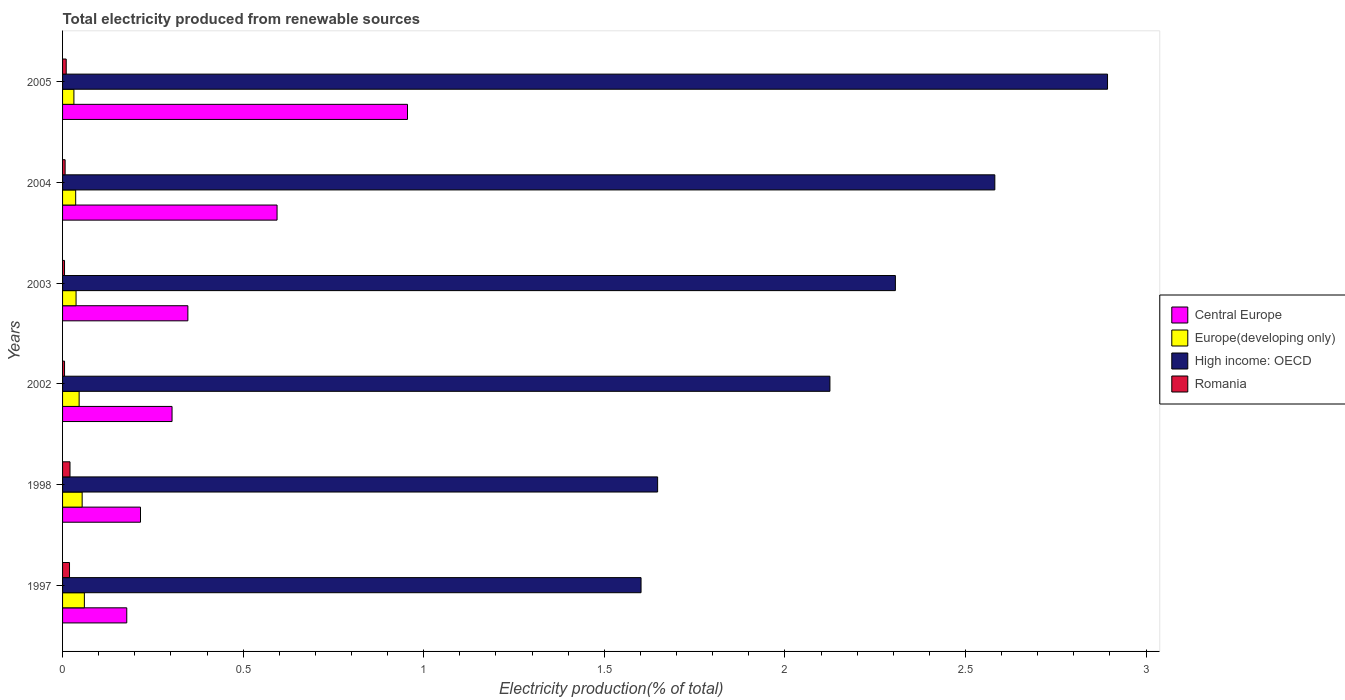How many different coloured bars are there?
Ensure brevity in your answer.  4. How many groups of bars are there?
Provide a short and direct response. 6. Are the number of bars per tick equal to the number of legend labels?
Provide a succinct answer. Yes. Are the number of bars on each tick of the Y-axis equal?
Provide a short and direct response. Yes. How many bars are there on the 2nd tick from the top?
Your answer should be very brief. 4. What is the label of the 1st group of bars from the top?
Provide a short and direct response. 2005. In how many cases, is the number of bars for a given year not equal to the number of legend labels?
Keep it short and to the point. 0. What is the total electricity produced in Romania in 1997?
Your answer should be compact. 0.02. Across all years, what is the maximum total electricity produced in High income: OECD?
Make the answer very short. 2.89. Across all years, what is the minimum total electricity produced in High income: OECD?
Offer a terse response. 1.6. In which year was the total electricity produced in Romania maximum?
Your answer should be very brief. 1998. In which year was the total electricity produced in Romania minimum?
Your answer should be very brief. 2003. What is the total total electricity produced in Central Europe in the graph?
Provide a succinct answer. 2.59. What is the difference between the total electricity produced in Central Europe in 1997 and that in 2003?
Offer a very short reply. -0.17. What is the difference between the total electricity produced in Europe(developing only) in 2004 and the total electricity produced in High income: OECD in 2003?
Give a very brief answer. -2.27. What is the average total electricity produced in High income: OECD per year?
Your response must be concise. 2.19. In the year 2005, what is the difference between the total electricity produced in Europe(developing only) and total electricity produced in High income: OECD?
Provide a short and direct response. -2.86. In how many years, is the total electricity produced in Romania greater than 2.8 %?
Ensure brevity in your answer.  0. What is the ratio of the total electricity produced in Central Europe in 1997 to that in 1998?
Your answer should be very brief. 0.82. What is the difference between the highest and the second highest total electricity produced in Romania?
Your answer should be very brief. 0. What is the difference between the highest and the lowest total electricity produced in Central Europe?
Make the answer very short. 0.78. Is the sum of the total electricity produced in Romania in 1997 and 2004 greater than the maximum total electricity produced in High income: OECD across all years?
Ensure brevity in your answer.  No. What does the 4th bar from the top in 1997 represents?
Make the answer very short. Central Europe. What does the 3rd bar from the bottom in 2003 represents?
Offer a very short reply. High income: OECD. Are all the bars in the graph horizontal?
Ensure brevity in your answer.  Yes. Does the graph contain any zero values?
Provide a short and direct response. No. How are the legend labels stacked?
Your answer should be very brief. Vertical. What is the title of the graph?
Provide a short and direct response. Total electricity produced from renewable sources. What is the Electricity production(% of total) in Central Europe in 1997?
Offer a very short reply. 0.18. What is the Electricity production(% of total) of Europe(developing only) in 1997?
Offer a terse response. 0.06. What is the Electricity production(% of total) of High income: OECD in 1997?
Provide a short and direct response. 1.6. What is the Electricity production(% of total) in Romania in 1997?
Offer a very short reply. 0.02. What is the Electricity production(% of total) in Central Europe in 1998?
Your answer should be compact. 0.22. What is the Electricity production(% of total) in Europe(developing only) in 1998?
Ensure brevity in your answer.  0.05. What is the Electricity production(% of total) of High income: OECD in 1998?
Your answer should be very brief. 1.65. What is the Electricity production(% of total) in Romania in 1998?
Ensure brevity in your answer.  0.02. What is the Electricity production(% of total) of Central Europe in 2002?
Keep it short and to the point. 0.3. What is the Electricity production(% of total) in Europe(developing only) in 2002?
Your answer should be compact. 0.05. What is the Electricity production(% of total) of High income: OECD in 2002?
Make the answer very short. 2.12. What is the Electricity production(% of total) of Romania in 2002?
Your answer should be very brief. 0.01. What is the Electricity production(% of total) of Central Europe in 2003?
Keep it short and to the point. 0.35. What is the Electricity production(% of total) in Europe(developing only) in 2003?
Your answer should be very brief. 0.04. What is the Electricity production(% of total) of High income: OECD in 2003?
Provide a short and direct response. 2.31. What is the Electricity production(% of total) of Romania in 2003?
Keep it short and to the point. 0.01. What is the Electricity production(% of total) in Central Europe in 2004?
Make the answer very short. 0.59. What is the Electricity production(% of total) of Europe(developing only) in 2004?
Offer a very short reply. 0.04. What is the Electricity production(% of total) of High income: OECD in 2004?
Make the answer very short. 2.58. What is the Electricity production(% of total) in Romania in 2004?
Your answer should be compact. 0.01. What is the Electricity production(% of total) of Central Europe in 2005?
Provide a succinct answer. 0.96. What is the Electricity production(% of total) in Europe(developing only) in 2005?
Your answer should be compact. 0.03. What is the Electricity production(% of total) in High income: OECD in 2005?
Provide a short and direct response. 2.89. What is the Electricity production(% of total) in Romania in 2005?
Your answer should be compact. 0.01. Across all years, what is the maximum Electricity production(% of total) of Central Europe?
Your response must be concise. 0.96. Across all years, what is the maximum Electricity production(% of total) of Europe(developing only)?
Offer a very short reply. 0.06. Across all years, what is the maximum Electricity production(% of total) in High income: OECD?
Provide a succinct answer. 2.89. Across all years, what is the maximum Electricity production(% of total) in Romania?
Give a very brief answer. 0.02. Across all years, what is the minimum Electricity production(% of total) of Central Europe?
Ensure brevity in your answer.  0.18. Across all years, what is the minimum Electricity production(% of total) of Europe(developing only)?
Your answer should be very brief. 0.03. Across all years, what is the minimum Electricity production(% of total) in High income: OECD?
Provide a short and direct response. 1.6. Across all years, what is the minimum Electricity production(% of total) in Romania?
Ensure brevity in your answer.  0.01. What is the total Electricity production(% of total) in Central Europe in the graph?
Offer a very short reply. 2.59. What is the total Electricity production(% of total) in Europe(developing only) in the graph?
Make the answer very short. 0.27. What is the total Electricity production(% of total) in High income: OECD in the graph?
Your response must be concise. 13.15. What is the total Electricity production(% of total) in Romania in the graph?
Give a very brief answer. 0.07. What is the difference between the Electricity production(% of total) in Central Europe in 1997 and that in 1998?
Ensure brevity in your answer.  -0.04. What is the difference between the Electricity production(% of total) in Europe(developing only) in 1997 and that in 1998?
Provide a succinct answer. 0.01. What is the difference between the Electricity production(% of total) of High income: OECD in 1997 and that in 1998?
Provide a succinct answer. -0.05. What is the difference between the Electricity production(% of total) of Romania in 1997 and that in 1998?
Provide a short and direct response. -0. What is the difference between the Electricity production(% of total) of Central Europe in 1997 and that in 2002?
Give a very brief answer. -0.13. What is the difference between the Electricity production(% of total) of Europe(developing only) in 1997 and that in 2002?
Your answer should be compact. 0.01. What is the difference between the Electricity production(% of total) of High income: OECD in 1997 and that in 2002?
Keep it short and to the point. -0.52. What is the difference between the Electricity production(% of total) in Romania in 1997 and that in 2002?
Offer a very short reply. 0.01. What is the difference between the Electricity production(% of total) in Central Europe in 1997 and that in 2003?
Offer a very short reply. -0.17. What is the difference between the Electricity production(% of total) of Europe(developing only) in 1997 and that in 2003?
Your answer should be very brief. 0.02. What is the difference between the Electricity production(% of total) in High income: OECD in 1997 and that in 2003?
Offer a terse response. -0.7. What is the difference between the Electricity production(% of total) of Romania in 1997 and that in 2003?
Provide a succinct answer. 0.01. What is the difference between the Electricity production(% of total) of Central Europe in 1997 and that in 2004?
Your answer should be very brief. -0.42. What is the difference between the Electricity production(% of total) in Europe(developing only) in 1997 and that in 2004?
Provide a short and direct response. 0.02. What is the difference between the Electricity production(% of total) in High income: OECD in 1997 and that in 2004?
Keep it short and to the point. -0.98. What is the difference between the Electricity production(% of total) in Romania in 1997 and that in 2004?
Offer a very short reply. 0.01. What is the difference between the Electricity production(% of total) in Central Europe in 1997 and that in 2005?
Your answer should be compact. -0.78. What is the difference between the Electricity production(% of total) in Europe(developing only) in 1997 and that in 2005?
Your answer should be compact. 0.03. What is the difference between the Electricity production(% of total) of High income: OECD in 1997 and that in 2005?
Make the answer very short. -1.29. What is the difference between the Electricity production(% of total) of Romania in 1997 and that in 2005?
Make the answer very short. 0.01. What is the difference between the Electricity production(% of total) in Central Europe in 1998 and that in 2002?
Your answer should be compact. -0.09. What is the difference between the Electricity production(% of total) of Europe(developing only) in 1998 and that in 2002?
Your response must be concise. 0.01. What is the difference between the Electricity production(% of total) in High income: OECD in 1998 and that in 2002?
Your response must be concise. -0.48. What is the difference between the Electricity production(% of total) in Romania in 1998 and that in 2002?
Provide a short and direct response. 0.02. What is the difference between the Electricity production(% of total) of Central Europe in 1998 and that in 2003?
Provide a short and direct response. -0.13. What is the difference between the Electricity production(% of total) of Europe(developing only) in 1998 and that in 2003?
Provide a succinct answer. 0.02. What is the difference between the Electricity production(% of total) in High income: OECD in 1998 and that in 2003?
Your answer should be compact. -0.66. What is the difference between the Electricity production(% of total) of Romania in 1998 and that in 2003?
Offer a terse response. 0.02. What is the difference between the Electricity production(% of total) of Central Europe in 1998 and that in 2004?
Provide a succinct answer. -0.38. What is the difference between the Electricity production(% of total) in Europe(developing only) in 1998 and that in 2004?
Your answer should be compact. 0.02. What is the difference between the Electricity production(% of total) of High income: OECD in 1998 and that in 2004?
Provide a short and direct response. -0.93. What is the difference between the Electricity production(% of total) in Romania in 1998 and that in 2004?
Your response must be concise. 0.01. What is the difference between the Electricity production(% of total) in Central Europe in 1998 and that in 2005?
Offer a very short reply. -0.74. What is the difference between the Electricity production(% of total) in Europe(developing only) in 1998 and that in 2005?
Provide a short and direct response. 0.02. What is the difference between the Electricity production(% of total) in High income: OECD in 1998 and that in 2005?
Offer a terse response. -1.25. What is the difference between the Electricity production(% of total) of Romania in 1998 and that in 2005?
Your answer should be very brief. 0.01. What is the difference between the Electricity production(% of total) of Central Europe in 2002 and that in 2003?
Make the answer very short. -0.04. What is the difference between the Electricity production(% of total) in Europe(developing only) in 2002 and that in 2003?
Offer a terse response. 0.01. What is the difference between the Electricity production(% of total) of High income: OECD in 2002 and that in 2003?
Provide a short and direct response. -0.18. What is the difference between the Electricity production(% of total) of Romania in 2002 and that in 2003?
Provide a short and direct response. 0. What is the difference between the Electricity production(% of total) of Central Europe in 2002 and that in 2004?
Offer a very short reply. -0.29. What is the difference between the Electricity production(% of total) of Europe(developing only) in 2002 and that in 2004?
Make the answer very short. 0.01. What is the difference between the Electricity production(% of total) in High income: OECD in 2002 and that in 2004?
Make the answer very short. -0.46. What is the difference between the Electricity production(% of total) of Romania in 2002 and that in 2004?
Ensure brevity in your answer.  -0. What is the difference between the Electricity production(% of total) of Central Europe in 2002 and that in 2005?
Ensure brevity in your answer.  -0.65. What is the difference between the Electricity production(% of total) in Europe(developing only) in 2002 and that in 2005?
Provide a succinct answer. 0.01. What is the difference between the Electricity production(% of total) of High income: OECD in 2002 and that in 2005?
Offer a terse response. -0.77. What is the difference between the Electricity production(% of total) of Romania in 2002 and that in 2005?
Offer a very short reply. -0. What is the difference between the Electricity production(% of total) in Central Europe in 2003 and that in 2004?
Provide a short and direct response. -0.25. What is the difference between the Electricity production(% of total) of High income: OECD in 2003 and that in 2004?
Your answer should be very brief. -0.28. What is the difference between the Electricity production(% of total) in Romania in 2003 and that in 2004?
Your answer should be very brief. -0. What is the difference between the Electricity production(% of total) of Central Europe in 2003 and that in 2005?
Your response must be concise. -0.61. What is the difference between the Electricity production(% of total) in Europe(developing only) in 2003 and that in 2005?
Keep it short and to the point. 0.01. What is the difference between the Electricity production(% of total) in High income: OECD in 2003 and that in 2005?
Ensure brevity in your answer.  -0.59. What is the difference between the Electricity production(% of total) in Romania in 2003 and that in 2005?
Make the answer very short. -0. What is the difference between the Electricity production(% of total) in Central Europe in 2004 and that in 2005?
Provide a succinct answer. -0.36. What is the difference between the Electricity production(% of total) in Europe(developing only) in 2004 and that in 2005?
Give a very brief answer. 0. What is the difference between the Electricity production(% of total) of High income: OECD in 2004 and that in 2005?
Ensure brevity in your answer.  -0.31. What is the difference between the Electricity production(% of total) of Romania in 2004 and that in 2005?
Your answer should be very brief. -0. What is the difference between the Electricity production(% of total) in Central Europe in 1997 and the Electricity production(% of total) in Europe(developing only) in 1998?
Make the answer very short. 0.12. What is the difference between the Electricity production(% of total) in Central Europe in 1997 and the Electricity production(% of total) in High income: OECD in 1998?
Make the answer very short. -1.47. What is the difference between the Electricity production(% of total) of Central Europe in 1997 and the Electricity production(% of total) of Romania in 1998?
Keep it short and to the point. 0.16. What is the difference between the Electricity production(% of total) of Europe(developing only) in 1997 and the Electricity production(% of total) of High income: OECD in 1998?
Give a very brief answer. -1.59. What is the difference between the Electricity production(% of total) of Europe(developing only) in 1997 and the Electricity production(% of total) of Romania in 1998?
Your answer should be compact. 0.04. What is the difference between the Electricity production(% of total) in High income: OECD in 1997 and the Electricity production(% of total) in Romania in 1998?
Provide a short and direct response. 1.58. What is the difference between the Electricity production(% of total) of Central Europe in 1997 and the Electricity production(% of total) of Europe(developing only) in 2002?
Make the answer very short. 0.13. What is the difference between the Electricity production(% of total) in Central Europe in 1997 and the Electricity production(% of total) in High income: OECD in 2002?
Your answer should be compact. -1.95. What is the difference between the Electricity production(% of total) in Central Europe in 1997 and the Electricity production(% of total) in Romania in 2002?
Provide a succinct answer. 0.17. What is the difference between the Electricity production(% of total) in Europe(developing only) in 1997 and the Electricity production(% of total) in High income: OECD in 2002?
Provide a succinct answer. -2.06. What is the difference between the Electricity production(% of total) in Europe(developing only) in 1997 and the Electricity production(% of total) in Romania in 2002?
Keep it short and to the point. 0.05. What is the difference between the Electricity production(% of total) of High income: OECD in 1997 and the Electricity production(% of total) of Romania in 2002?
Your answer should be very brief. 1.6. What is the difference between the Electricity production(% of total) of Central Europe in 1997 and the Electricity production(% of total) of Europe(developing only) in 2003?
Provide a succinct answer. 0.14. What is the difference between the Electricity production(% of total) of Central Europe in 1997 and the Electricity production(% of total) of High income: OECD in 2003?
Offer a terse response. -2.13. What is the difference between the Electricity production(% of total) in Central Europe in 1997 and the Electricity production(% of total) in Romania in 2003?
Offer a very short reply. 0.17. What is the difference between the Electricity production(% of total) in Europe(developing only) in 1997 and the Electricity production(% of total) in High income: OECD in 2003?
Make the answer very short. -2.25. What is the difference between the Electricity production(% of total) in Europe(developing only) in 1997 and the Electricity production(% of total) in Romania in 2003?
Offer a terse response. 0.05. What is the difference between the Electricity production(% of total) of High income: OECD in 1997 and the Electricity production(% of total) of Romania in 2003?
Keep it short and to the point. 1.6. What is the difference between the Electricity production(% of total) of Central Europe in 1997 and the Electricity production(% of total) of Europe(developing only) in 2004?
Keep it short and to the point. 0.14. What is the difference between the Electricity production(% of total) in Central Europe in 1997 and the Electricity production(% of total) in High income: OECD in 2004?
Provide a succinct answer. -2.4. What is the difference between the Electricity production(% of total) in Central Europe in 1997 and the Electricity production(% of total) in Romania in 2004?
Provide a succinct answer. 0.17. What is the difference between the Electricity production(% of total) of Europe(developing only) in 1997 and the Electricity production(% of total) of High income: OECD in 2004?
Provide a succinct answer. -2.52. What is the difference between the Electricity production(% of total) of Europe(developing only) in 1997 and the Electricity production(% of total) of Romania in 2004?
Your response must be concise. 0.05. What is the difference between the Electricity production(% of total) of High income: OECD in 1997 and the Electricity production(% of total) of Romania in 2004?
Keep it short and to the point. 1.59. What is the difference between the Electricity production(% of total) of Central Europe in 1997 and the Electricity production(% of total) of Europe(developing only) in 2005?
Ensure brevity in your answer.  0.15. What is the difference between the Electricity production(% of total) in Central Europe in 1997 and the Electricity production(% of total) in High income: OECD in 2005?
Give a very brief answer. -2.72. What is the difference between the Electricity production(% of total) of Central Europe in 1997 and the Electricity production(% of total) of Romania in 2005?
Offer a very short reply. 0.17. What is the difference between the Electricity production(% of total) of Europe(developing only) in 1997 and the Electricity production(% of total) of High income: OECD in 2005?
Your response must be concise. -2.83. What is the difference between the Electricity production(% of total) of Europe(developing only) in 1997 and the Electricity production(% of total) of Romania in 2005?
Provide a succinct answer. 0.05. What is the difference between the Electricity production(% of total) in High income: OECD in 1997 and the Electricity production(% of total) in Romania in 2005?
Your answer should be very brief. 1.59. What is the difference between the Electricity production(% of total) of Central Europe in 1998 and the Electricity production(% of total) of Europe(developing only) in 2002?
Offer a terse response. 0.17. What is the difference between the Electricity production(% of total) in Central Europe in 1998 and the Electricity production(% of total) in High income: OECD in 2002?
Provide a succinct answer. -1.91. What is the difference between the Electricity production(% of total) of Central Europe in 1998 and the Electricity production(% of total) of Romania in 2002?
Keep it short and to the point. 0.21. What is the difference between the Electricity production(% of total) of Europe(developing only) in 1998 and the Electricity production(% of total) of High income: OECD in 2002?
Ensure brevity in your answer.  -2.07. What is the difference between the Electricity production(% of total) of Europe(developing only) in 1998 and the Electricity production(% of total) of Romania in 2002?
Offer a terse response. 0.05. What is the difference between the Electricity production(% of total) in High income: OECD in 1998 and the Electricity production(% of total) in Romania in 2002?
Provide a short and direct response. 1.64. What is the difference between the Electricity production(% of total) of Central Europe in 1998 and the Electricity production(% of total) of Europe(developing only) in 2003?
Your response must be concise. 0.18. What is the difference between the Electricity production(% of total) of Central Europe in 1998 and the Electricity production(% of total) of High income: OECD in 2003?
Provide a short and direct response. -2.09. What is the difference between the Electricity production(% of total) in Central Europe in 1998 and the Electricity production(% of total) in Romania in 2003?
Offer a terse response. 0.21. What is the difference between the Electricity production(% of total) of Europe(developing only) in 1998 and the Electricity production(% of total) of High income: OECD in 2003?
Your response must be concise. -2.25. What is the difference between the Electricity production(% of total) of Europe(developing only) in 1998 and the Electricity production(% of total) of Romania in 2003?
Your answer should be very brief. 0.05. What is the difference between the Electricity production(% of total) of High income: OECD in 1998 and the Electricity production(% of total) of Romania in 2003?
Ensure brevity in your answer.  1.64. What is the difference between the Electricity production(% of total) of Central Europe in 1998 and the Electricity production(% of total) of Europe(developing only) in 2004?
Provide a succinct answer. 0.18. What is the difference between the Electricity production(% of total) of Central Europe in 1998 and the Electricity production(% of total) of High income: OECD in 2004?
Provide a short and direct response. -2.37. What is the difference between the Electricity production(% of total) in Central Europe in 1998 and the Electricity production(% of total) in Romania in 2004?
Offer a very short reply. 0.21. What is the difference between the Electricity production(% of total) of Europe(developing only) in 1998 and the Electricity production(% of total) of High income: OECD in 2004?
Provide a short and direct response. -2.53. What is the difference between the Electricity production(% of total) in Europe(developing only) in 1998 and the Electricity production(% of total) in Romania in 2004?
Keep it short and to the point. 0.05. What is the difference between the Electricity production(% of total) in High income: OECD in 1998 and the Electricity production(% of total) in Romania in 2004?
Provide a succinct answer. 1.64. What is the difference between the Electricity production(% of total) in Central Europe in 1998 and the Electricity production(% of total) in Europe(developing only) in 2005?
Your answer should be compact. 0.18. What is the difference between the Electricity production(% of total) of Central Europe in 1998 and the Electricity production(% of total) of High income: OECD in 2005?
Your answer should be compact. -2.68. What is the difference between the Electricity production(% of total) in Central Europe in 1998 and the Electricity production(% of total) in Romania in 2005?
Provide a short and direct response. 0.21. What is the difference between the Electricity production(% of total) in Europe(developing only) in 1998 and the Electricity production(% of total) in High income: OECD in 2005?
Offer a terse response. -2.84. What is the difference between the Electricity production(% of total) of Europe(developing only) in 1998 and the Electricity production(% of total) of Romania in 2005?
Your response must be concise. 0.04. What is the difference between the Electricity production(% of total) of High income: OECD in 1998 and the Electricity production(% of total) of Romania in 2005?
Make the answer very short. 1.64. What is the difference between the Electricity production(% of total) in Central Europe in 2002 and the Electricity production(% of total) in Europe(developing only) in 2003?
Your response must be concise. 0.27. What is the difference between the Electricity production(% of total) of Central Europe in 2002 and the Electricity production(% of total) of High income: OECD in 2003?
Ensure brevity in your answer.  -2. What is the difference between the Electricity production(% of total) in Central Europe in 2002 and the Electricity production(% of total) in Romania in 2003?
Provide a succinct answer. 0.3. What is the difference between the Electricity production(% of total) in Europe(developing only) in 2002 and the Electricity production(% of total) in High income: OECD in 2003?
Your answer should be very brief. -2.26. What is the difference between the Electricity production(% of total) of Europe(developing only) in 2002 and the Electricity production(% of total) of Romania in 2003?
Your answer should be very brief. 0.04. What is the difference between the Electricity production(% of total) of High income: OECD in 2002 and the Electricity production(% of total) of Romania in 2003?
Your answer should be compact. 2.12. What is the difference between the Electricity production(% of total) in Central Europe in 2002 and the Electricity production(% of total) in Europe(developing only) in 2004?
Provide a succinct answer. 0.27. What is the difference between the Electricity production(% of total) in Central Europe in 2002 and the Electricity production(% of total) in High income: OECD in 2004?
Give a very brief answer. -2.28. What is the difference between the Electricity production(% of total) of Central Europe in 2002 and the Electricity production(% of total) of Romania in 2004?
Make the answer very short. 0.3. What is the difference between the Electricity production(% of total) in Europe(developing only) in 2002 and the Electricity production(% of total) in High income: OECD in 2004?
Offer a terse response. -2.54. What is the difference between the Electricity production(% of total) in Europe(developing only) in 2002 and the Electricity production(% of total) in Romania in 2004?
Your answer should be very brief. 0.04. What is the difference between the Electricity production(% of total) in High income: OECD in 2002 and the Electricity production(% of total) in Romania in 2004?
Ensure brevity in your answer.  2.12. What is the difference between the Electricity production(% of total) of Central Europe in 2002 and the Electricity production(% of total) of Europe(developing only) in 2005?
Your response must be concise. 0.27. What is the difference between the Electricity production(% of total) of Central Europe in 2002 and the Electricity production(% of total) of High income: OECD in 2005?
Make the answer very short. -2.59. What is the difference between the Electricity production(% of total) in Central Europe in 2002 and the Electricity production(% of total) in Romania in 2005?
Provide a succinct answer. 0.29. What is the difference between the Electricity production(% of total) of Europe(developing only) in 2002 and the Electricity production(% of total) of High income: OECD in 2005?
Provide a short and direct response. -2.85. What is the difference between the Electricity production(% of total) in Europe(developing only) in 2002 and the Electricity production(% of total) in Romania in 2005?
Ensure brevity in your answer.  0.04. What is the difference between the Electricity production(% of total) of High income: OECD in 2002 and the Electricity production(% of total) of Romania in 2005?
Give a very brief answer. 2.11. What is the difference between the Electricity production(% of total) of Central Europe in 2003 and the Electricity production(% of total) of Europe(developing only) in 2004?
Offer a terse response. 0.31. What is the difference between the Electricity production(% of total) in Central Europe in 2003 and the Electricity production(% of total) in High income: OECD in 2004?
Ensure brevity in your answer.  -2.23. What is the difference between the Electricity production(% of total) in Central Europe in 2003 and the Electricity production(% of total) in Romania in 2004?
Keep it short and to the point. 0.34. What is the difference between the Electricity production(% of total) in Europe(developing only) in 2003 and the Electricity production(% of total) in High income: OECD in 2004?
Keep it short and to the point. -2.54. What is the difference between the Electricity production(% of total) in Europe(developing only) in 2003 and the Electricity production(% of total) in Romania in 2004?
Keep it short and to the point. 0.03. What is the difference between the Electricity production(% of total) in High income: OECD in 2003 and the Electricity production(% of total) in Romania in 2004?
Your answer should be very brief. 2.3. What is the difference between the Electricity production(% of total) of Central Europe in 2003 and the Electricity production(% of total) of Europe(developing only) in 2005?
Offer a terse response. 0.32. What is the difference between the Electricity production(% of total) in Central Europe in 2003 and the Electricity production(% of total) in High income: OECD in 2005?
Keep it short and to the point. -2.55. What is the difference between the Electricity production(% of total) of Central Europe in 2003 and the Electricity production(% of total) of Romania in 2005?
Offer a very short reply. 0.34. What is the difference between the Electricity production(% of total) of Europe(developing only) in 2003 and the Electricity production(% of total) of High income: OECD in 2005?
Make the answer very short. -2.86. What is the difference between the Electricity production(% of total) of Europe(developing only) in 2003 and the Electricity production(% of total) of Romania in 2005?
Give a very brief answer. 0.03. What is the difference between the Electricity production(% of total) of High income: OECD in 2003 and the Electricity production(% of total) of Romania in 2005?
Offer a very short reply. 2.3. What is the difference between the Electricity production(% of total) in Central Europe in 2004 and the Electricity production(% of total) in Europe(developing only) in 2005?
Your answer should be compact. 0.56. What is the difference between the Electricity production(% of total) in Central Europe in 2004 and the Electricity production(% of total) in High income: OECD in 2005?
Give a very brief answer. -2.3. What is the difference between the Electricity production(% of total) of Central Europe in 2004 and the Electricity production(% of total) of Romania in 2005?
Offer a very short reply. 0.58. What is the difference between the Electricity production(% of total) of Europe(developing only) in 2004 and the Electricity production(% of total) of High income: OECD in 2005?
Provide a succinct answer. -2.86. What is the difference between the Electricity production(% of total) in Europe(developing only) in 2004 and the Electricity production(% of total) in Romania in 2005?
Your answer should be compact. 0.03. What is the difference between the Electricity production(% of total) of High income: OECD in 2004 and the Electricity production(% of total) of Romania in 2005?
Make the answer very short. 2.57. What is the average Electricity production(% of total) of Central Europe per year?
Provide a succinct answer. 0.43. What is the average Electricity production(% of total) in Europe(developing only) per year?
Your answer should be compact. 0.04. What is the average Electricity production(% of total) in High income: OECD per year?
Keep it short and to the point. 2.19. What is the average Electricity production(% of total) in Romania per year?
Provide a succinct answer. 0.01. In the year 1997, what is the difference between the Electricity production(% of total) in Central Europe and Electricity production(% of total) in Europe(developing only)?
Your response must be concise. 0.12. In the year 1997, what is the difference between the Electricity production(% of total) of Central Europe and Electricity production(% of total) of High income: OECD?
Your answer should be compact. -1.42. In the year 1997, what is the difference between the Electricity production(% of total) of Central Europe and Electricity production(% of total) of Romania?
Offer a very short reply. 0.16. In the year 1997, what is the difference between the Electricity production(% of total) of Europe(developing only) and Electricity production(% of total) of High income: OECD?
Make the answer very short. -1.54. In the year 1997, what is the difference between the Electricity production(% of total) in Europe(developing only) and Electricity production(% of total) in Romania?
Make the answer very short. 0.04. In the year 1997, what is the difference between the Electricity production(% of total) in High income: OECD and Electricity production(% of total) in Romania?
Your answer should be compact. 1.58. In the year 1998, what is the difference between the Electricity production(% of total) of Central Europe and Electricity production(% of total) of Europe(developing only)?
Give a very brief answer. 0.16. In the year 1998, what is the difference between the Electricity production(% of total) of Central Europe and Electricity production(% of total) of High income: OECD?
Your response must be concise. -1.43. In the year 1998, what is the difference between the Electricity production(% of total) in Central Europe and Electricity production(% of total) in Romania?
Offer a very short reply. 0.2. In the year 1998, what is the difference between the Electricity production(% of total) in Europe(developing only) and Electricity production(% of total) in High income: OECD?
Ensure brevity in your answer.  -1.59. In the year 1998, what is the difference between the Electricity production(% of total) of Europe(developing only) and Electricity production(% of total) of Romania?
Give a very brief answer. 0.03. In the year 1998, what is the difference between the Electricity production(% of total) of High income: OECD and Electricity production(% of total) of Romania?
Provide a short and direct response. 1.63. In the year 2002, what is the difference between the Electricity production(% of total) in Central Europe and Electricity production(% of total) in Europe(developing only)?
Your response must be concise. 0.26. In the year 2002, what is the difference between the Electricity production(% of total) of Central Europe and Electricity production(% of total) of High income: OECD?
Offer a terse response. -1.82. In the year 2002, what is the difference between the Electricity production(% of total) of Central Europe and Electricity production(% of total) of Romania?
Your answer should be very brief. 0.3. In the year 2002, what is the difference between the Electricity production(% of total) in Europe(developing only) and Electricity production(% of total) in High income: OECD?
Make the answer very short. -2.08. In the year 2002, what is the difference between the Electricity production(% of total) of Europe(developing only) and Electricity production(% of total) of Romania?
Provide a succinct answer. 0.04. In the year 2002, what is the difference between the Electricity production(% of total) in High income: OECD and Electricity production(% of total) in Romania?
Make the answer very short. 2.12. In the year 2003, what is the difference between the Electricity production(% of total) in Central Europe and Electricity production(% of total) in Europe(developing only)?
Keep it short and to the point. 0.31. In the year 2003, what is the difference between the Electricity production(% of total) in Central Europe and Electricity production(% of total) in High income: OECD?
Your response must be concise. -1.96. In the year 2003, what is the difference between the Electricity production(% of total) of Central Europe and Electricity production(% of total) of Romania?
Your answer should be very brief. 0.34. In the year 2003, what is the difference between the Electricity production(% of total) in Europe(developing only) and Electricity production(% of total) in High income: OECD?
Your answer should be compact. -2.27. In the year 2003, what is the difference between the Electricity production(% of total) in Europe(developing only) and Electricity production(% of total) in Romania?
Your response must be concise. 0.03. In the year 2003, what is the difference between the Electricity production(% of total) of High income: OECD and Electricity production(% of total) of Romania?
Your response must be concise. 2.3. In the year 2004, what is the difference between the Electricity production(% of total) in Central Europe and Electricity production(% of total) in Europe(developing only)?
Your answer should be very brief. 0.56. In the year 2004, what is the difference between the Electricity production(% of total) in Central Europe and Electricity production(% of total) in High income: OECD?
Make the answer very short. -1.99. In the year 2004, what is the difference between the Electricity production(% of total) of Central Europe and Electricity production(% of total) of Romania?
Offer a terse response. 0.59. In the year 2004, what is the difference between the Electricity production(% of total) in Europe(developing only) and Electricity production(% of total) in High income: OECD?
Offer a terse response. -2.54. In the year 2004, what is the difference between the Electricity production(% of total) of Europe(developing only) and Electricity production(% of total) of Romania?
Offer a terse response. 0.03. In the year 2004, what is the difference between the Electricity production(% of total) of High income: OECD and Electricity production(% of total) of Romania?
Provide a short and direct response. 2.57. In the year 2005, what is the difference between the Electricity production(% of total) of Central Europe and Electricity production(% of total) of Europe(developing only)?
Make the answer very short. 0.92. In the year 2005, what is the difference between the Electricity production(% of total) of Central Europe and Electricity production(% of total) of High income: OECD?
Your response must be concise. -1.94. In the year 2005, what is the difference between the Electricity production(% of total) of Central Europe and Electricity production(% of total) of Romania?
Provide a short and direct response. 0.94. In the year 2005, what is the difference between the Electricity production(% of total) in Europe(developing only) and Electricity production(% of total) in High income: OECD?
Offer a very short reply. -2.86. In the year 2005, what is the difference between the Electricity production(% of total) of Europe(developing only) and Electricity production(% of total) of Romania?
Your answer should be compact. 0.02. In the year 2005, what is the difference between the Electricity production(% of total) of High income: OECD and Electricity production(% of total) of Romania?
Make the answer very short. 2.88. What is the ratio of the Electricity production(% of total) in Central Europe in 1997 to that in 1998?
Keep it short and to the point. 0.82. What is the ratio of the Electricity production(% of total) in Europe(developing only) in 1997 to that in 1998?
Provide a short and direct response. 1.11. What is the ratio of the Electricity production(% of total) in High income: OECD in 1997 to that in 1998?
Offer a very short reply. 0.97. What is the ratio of the Electricity production(% of total) of Romania in 1997 to that in 1998?
Give a very brief answer. 0.94. What is the ratio of the Electricity production(% of total) in Central Europe in 1997 to that in 2002?
Make the answer very short. 0.59. What is the ratio of the Electricity production(% of total) in Europe(developing only) in 1997 to that in 2002?
Your answer should be compact. 1.32. What is the ratio of the Electricity production(% of total) in High income: OECD in 1997 to that in 2002?
Your answer should be very brief. 0.75. What is the ratio of the Electricity production(% of total) in Romania in 1997 to that in 2002?
Make the answer very short. 3.51. What is the ratio of the Electricity production(% of total) of Central Europe in 1997 to that in 2003?
Offer a terse response. 0.51. What is the ratio of the Electricity production(% of total) in Europe(developing only) in 1997 to that in 2003?
Give a very brief answer. 1.62. What is the ratio of the Electricity production(% of total) in High income: OECD in 1997 to that in 2003?
Offer a very short reply. 0.69. What is the ratio of the Electricity production(% of total) of Romania in 1997 to that in 2003?
Offer a very short reply. 3.54. What is the ratio of the Electricity production(% of total) of Central Europe in 1997 to that in 2004?
Keep it short and to the point. 0.3. What is the ratio of the Electricity production(% of total) of Europe(developing only) in 1997 to that in 2004?
Provide a succinct answer. 1.66. What is the ratio of the Electricity production(% of total) in High income: OECD in 1997 to that in 2004?
Provide a short and direct response. 0.62. What is the ratio of the Electricity production(% of total) of Romania in 1997 to that in 2004?
Provide a succinct answer. 2.72. What is the ratio of the Electricity production(% of total) in Central Europe in 1997 to that in 2005?
Ensure brevity in your answer.  0.19. What is the ratio of the Electricity production(% of total) in Europe(developing only) in 1997 to that in 2005?
Give a very brief answer. 1.92. What is the ratio of the Electricity production(% of total) of High income: OECD in 1997 to that in 2005?
Make the answer very short. 0.55. What is the ratio of the Electricity production(% of total) of Romania in 1997 to that in 2005?
Your answer should be compact. 1.91. What is the ratio of the Electricity production(% of total) in Central Europe in 1998 to that in 2002?
Your answer should be compact. 0.71. What is the ratio of the Electricity production(% of total) in Europe(developing only) in 1998 to that in 2002?
Make the answer very short. 1.18. What is the ratio of the Electricity production(% of total) in High income: OECD in 1998 to that in 2002?
Offer a terse response. 0.78. What is the ratio of the Electricity production(% of total) of Romania in 1998 to that in 2002?
Give a very brief answer. 3.75. What is the ratio of the Electricity production(% of total) of Central Europe in 1998 to that in 2003?
Keep it short and to the point. 0.62. What is the ratio of the Electricity production(% of total) in Europe(developing only) in 1998 to that in 2003?
Make the answer very short. 1.45. What is the ratio of the Electricity production(% of total) in High income: OECD in 1998 to that in 2003?
Your answer should be compact. 0.71. What is the ratio of the Electricity production(% of total) of Romania in 1998 to that in 2003?
Offer a terse response. 3.78. What is the ratio of the Electricity production(% of total) of Central Europe in 1998 to that in 2004?
Your answer should be compact. 0.36. What is the ratio of the Electricity production(% of total) in Europe(developing only) in 1998 to that in 2004?
Provide a succinct answer. 1.49. What is the ratio of the Electricity production(% of total) of High income: OECD in 1998 to that in 2004?
Ensure brevity in your answer.  0.64. What is the ratio of the Electricity production(% of total) in Romania in 1998 to that in 2004?
Keep it short and to the point. 2.9. What is the ratio of the Electricity production(% of total) in Central Europe in 1998 to that in 2005?
Provide a succinct answer. 0.23. What is the ratio of the Electricity production(% of total) in Europe(developing only) in 1998 to that in 2005?
Give a very brief answer. 1.73. What is the ratio of the Electricity production(% of total) in High income: OECD in 1998 to that in 2005?
Keep it short and to the point. 0.57. What is the ratio of the Electricity production(% of total) of Romania in 1998 to that in 2005?
Your answer should be very brief. 2.04. What is the ratio of the Electricity production(% of total) in Central Europe in 2002 to that in 2003?
Your answer should be very brief. 0.87. What is the ratio of the Electricity production(% of total) of Europe(developing only) in 2002 to that in 2003?
Ensure brevity in your answer.  1.23. What is the ratio of the Electricity production(% of total) in High income: OECD in 2002 to that in 2003?
Provide a succinct answer. 0.92. What is the ratio of the Electricity production(% of total) in Romania in 2002 to that in 2003?
Make the answer very short. 1.01. What is the ratio of the Electricity production(% of total) in Central Europe in 2002 to that in 2004?
Provide a short and direct response. 0.51. What is the ratio of the Electricity production(% of total) in Europe(developing only) in 2002 to that in 2004?
Your answer should be very brief. 1.26. What is the ratio of the Electricity production(% of total) of High income: OECD in 2002 to that in 2004?
Keep it short and to the point. 0.82. What is the ratio of the Electricity production(% of total) in Romania in 2002 to that in 2004?
Offer a very short reply. 0.77. What is the ratio of the Electricity production(% of total) of Central Europe in 2002 to that in 2005?
Give a very brief answer. 0.32. What is the ratio of the Electricity production(% of total) in Europe(developing only) in 2002 to that in 2005?
Offer a terse response. 1.46. What is the ratio of the Electricity production(% of total) in High income: OECD in 2002 to that in 2005?
Give a very brief answer. 0.73. What is the ratio of the Electricity production(% of total) of Romania in 2002 to that in 2005?
Keep it short and to the point. 0.54. What is the ratio of the Electricity production(% of total) in Central Europe in 2003 to that in 2004?
Keep it short and to the point. 0.58. What is the ratio of the Electricity production(% of total) of Europe(developing only) in 2003 to that in 2004?
Provide a short and direct response. 1.03. What is the ratio of the Electricity production(% of total) in High income: OECD in 2003 to that in 2004?
Offer a very short reply. 0.89. What is the ratio of the Electricity production(% of total) in Romania in 2003 to that in 2004?
Your answer should be compact. 0.77. What is the ratio of the Electricity production(% of total) of Central Europe in 2003 to that in 2005?
Provide a succinct answer. 0.36. What is the ratio of the Electricity production(% of total) of Europe(developing only) in 2003 to that in 2005?
Provide a succinct answer. 1.19. What is the ratio of the Electricity production(% of total) in High income: OECD in 2003 to that in 2005?
Give a very brief answer. 0.8. What is the ratio of the Electricity production(% of total) of Romania in 2003 to that in 2005?
Your answer should be very brief. 0.54. What is the ratio of the Electricity production(% of total) in Central Europe in 2004 to that in 2005?
Provide a succinct answer. 0.62. What is the ratio of the Electricity production(% of total) in Europe(developing only) in 2004 to that in 2005?
Your answer should be compact. 1.16. What is the ratio of the Electricity production(% of total) of High income: OECD in 2004 to that in 2005?
Your response must be concise. 0.89. What is the ratio of the Electricity production(% of total) of Romania in 2004 to that in 2005?
Offer a terse response. 0.7. What is the difference between the highest and the second highest Electricity production(% of total) in Central Europe?
Give a very brief answer. 0.36. What is the difference between the highest and the second highest Electricity production(% of total) in Europe(developing only)?
Your answer should be compact. 0.01. What is the difference between the highest and the second highest Electricity production(% of total) in High income: OECD?
Offer a very short reply. 0.31. What is the difference between the highest and the second highest Electricity production(% of total) of Romania?
Provide a succinct answer. 0. What is the difference between the highest and the lowest Electricity production(% of total) in Central Europe?
Your answer should be very brief. 0.78. What is the difference between the highest and the lowest Electricity production(% of total) in Europe(developing only)?
Ensure brevity in your answer.  0.03. What is the difference between the highest and the lowest Electricity production(% of total) in High income: OECD?
Ensure brevity in your answer.  1.29. What is the difference between the highest and the lowest Electricity production(% of total) in Romania?
Provide a short and direct response. 0.02. 